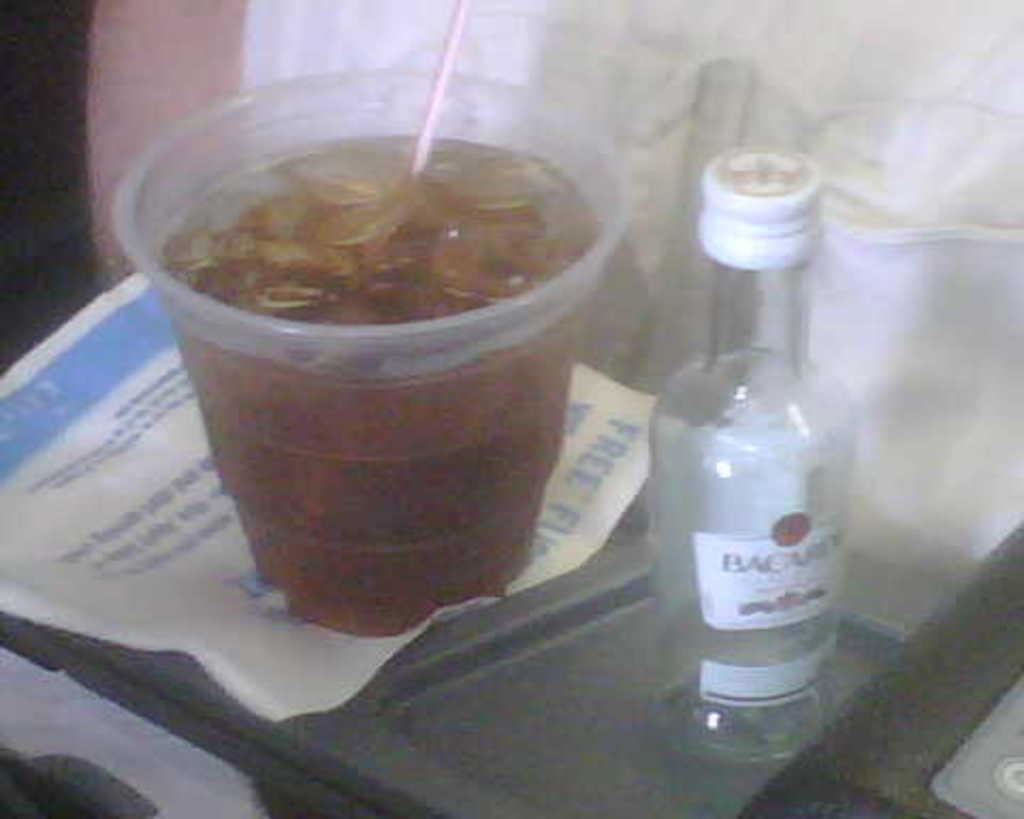Provide a one-sentence caption for the provided image. A small bottle with a white cap that is labelled "Bacardi". 